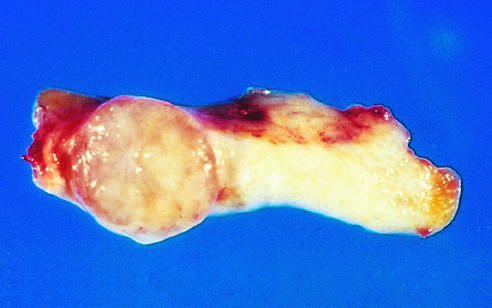what is the tan-colored, encapsulated small tumor demarcated from?
Answer the question using a single word or phrase. The whiter breast tissue 